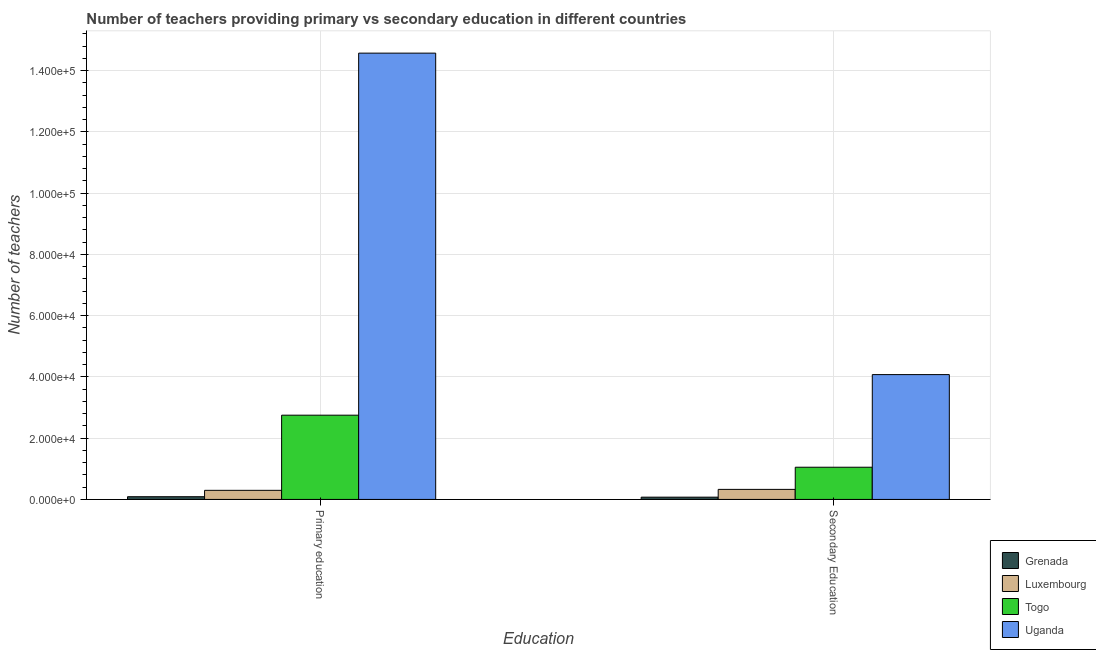How many different coloured bars are there?
Make the answer very short. 4. How many groups of bars are there?
Your response must be concise. 2. Are the number of bars per tick equal to the number of legend labels?
Your response must be concise. Yes. How many bars are there on the 2nd tick from the right?
Keep it short and to the point. 4. What is the number of primary teachers in Luxembourg?
Offer a very short reply. 2966. Across all countries, what is the maximum number of primary teachers?
Keep it short and to the point. 1.46e+05. Across all countries, what is the minimum number of primary teachers?
Offer a terse response. 888. In which country was the number of primary teachers maximum?
Keep it short and to the point. Uganda. In which country was the number of secondary teachers minimum?
Provide a succinct answer. Grenada. What is the total number of primary teachers in the graph?
Ensure brevity in your answer.  1.77e+05. What is the difference between the number of primary teachers in Togo and that in Luxembourg?
Provide a succinct answer. 2.45e+04. What is the difference between the number of primary teachers in Luxembourg and the number of secondary teachers in Uganda?
Offer a very short reply. -3.78e+04. What is the average number of secondary teachers per country?
Keep it short and to the point. 1.38e+04. What is the difference between the number of primary teachers and number of secondary teachers in Togo?
Provide a succinct answer. 1.70e+04. What is the ratio of the number of primary teachers in Uganda to that in Togo?
Offer a very short reply. 5.3. What does the 1st bar from the left in Primary education represents?
Keep it short and to the point. Grenada. What does the 1st bar from the right in Secondary Education represents?
Provide a short and direct response. Uganda. How many bars are there?
Your answer should be compact. 8. How many countries are there in the graph?
Keep it short and to the point. 4. What is the difference between two consecutive major ticks on the Y-axis?
Make the answer very short. 2.00e+04. Are the values on the major ticks of Y-axis written in scientific E-notation?
Give a very brief answer. Yes. Does the graph contain grids?
Keep it short and to the point. Yes. How are the legend labels stacked?
Your response must be concise. Vertical. What is the title of the graph?
Give a very brief answer. Number of teachers providing primary vs secondary education in different countries. What is the label or title of the X-axis?
Your response must be concise. Education. What is the label or title of the Y-axis?
Your answer should be very brief. Number of teachers. What is the Number of teachers of Grenada in Primary education?
Your answer should be compact. 888. What is the Number of teachers of Luxembourg in Primary education?
Offer a very short reply. 2966. What is the Number of teachers of Togo in Primary education?
Make the answer very short. 2.75e+04. What is the Number of teachers of Uganda in Primary education?
Ensure brevity in your answer.  1.46e+05. What is the Number of teachers of Grenada in Secondary Education?
Your response must be concise. 740. What is the Number of teachers in Luxembourg in Secondary Education?
Your response must be concise. 3279. What is the Number of teachers in Togo in Secondary Education?
Keep it short and to the point. 1.05e+04. What is the Number of teachers in Uganda in Secondary Education?
Provide a succinct answer. 4.08e+04. Across all Education, what is the maximum Number of teachers of Grenada?
Your answer should be very brief. 888. Across all Education, what is the maximum Number of teachers in Luxembourg?
Give a very brief answer. 3279. Across all Education, what is the maximum Number of teachers in Togo?
Make the answer very short. 2.75e+04. Across all Education, what is the maximum Number of teachers in Uganda?
Make the answer very short. 1.46e+05. Across all Education, what is the minimum Number of teachers in Grenada?
Keep it short and to the point. 740. Across all Education, what is the minimum Number of teachers of Luxembourg?
Provide a short and direct response. 2966. Across all Education, what is the minimum Number of teachers in Togo?
Your answer should be very brief. 1.05e+04. Across all Education, what is the minimum Number of teachers of Uganda?
Make the answer very short. 4.08e+04. What is the total Number of teachers of Grenada in the graph?
Make the answer very short. 1628. What is the total Number of teachers of Luxembourg in the graph?
Your answer should be very brief. 6245. What is the total Number of teachers of Togo in the graph?
Make the answer very short. 3.80e+04. What is the total Number of teachers of Uganda in the graph?
Your answer should be very brief. 1.86e+05. What is the difference between the Number of teachers in Grenada in Primary education and that in Secondary Education?
Offer a very short reply. 148. What is the difference between the Number of teachers of Luxembourg in Primary education and that in Secondary Education?
Ensure brevity in your answer.  -313. What is the difference between the Number of teachers in Togo in Primary education and that in Secondary Education?
Provide a succinct answer. 1.70e+04. What is the difference between the Number of teachers in Uganda in Primary education and that in Secondary Education?
Ensure brevity in your answer.  1.05e+05. What is the difference between the Number of teachers in Grenada in Primary education and the Number of teachers in Luxembourg in Secondary Education?
Keep it short and to the point. -2391. What is the difference between the Number of teachers in Grenada in Primary education and the Number of teachers in Togo in Secondary Education?
Your answer should be very brief. -9625. What is the difference between the Number of teachers of Grenada in Primary education and the Number of teachers of Uganda in Secondary Education?
Your answer should be compact. -3.99e+04. What is the difference between the Number of teachers of Luxembourg in Primary education and the Number of teachers of Togo in Secondary Education?
Keep it short and to the point. -7547. What is the difference between the Number of teachers of Luxembourg in Primary education and the Number of teachers of Uganda in Secondary Education?
Make the answer very short. -3.78e+04. What is the difference between the Number of teachers in Togo in Primary education and the Number of teachers in Uganda in Secondary Education?
Keep it short and to the point. -1.32e+04. What is the average Number of teachers in Grenada per Education?
Make the answer very short. 814. What is the average Number of teachers in Luxembourg per Education?
Your response must be concise. 3122.5. What is the average Number of teachers in Togo per Education?
Give a very brief answer. 1.90e+04. What is the average Number of teachers in Uganda per Education?
Give a very brief answer. 9.32e+04. What is the difference between the Number of teachers in Grenada and Number of teachers in Luxembourg in Primary education?
Ensure brevity in your answer.  -2078. What is the difference between the Number of teachers in Grenada and Number of teachers in Togo in Primary education?
Keep it short and to the point. -2.66e+04. What is the difference between the Number of teachers in Grenada and Number of teachers in Uganda in Primary education?
Make the answer very short. -1.45e+05. What is the difference between the Number of teachers in Luxembourg and Number of teachers in Togo in Primary education?
Your answer should be compact. -2.45e+04. What is the difference between the Number of teachers in Luxembourg and Number of teachers in Uganda in Primary education?
Offer a very short reply. -1.43e+05. What is the difference between the Number of teachers in Togo and Number of teachers in Uganda in Primary education?
Give a very brief answer. -1.18e+05. What is the difference between the Number of teachers in Grenada and Number of teachers in Luxembourg in Secondary Education?
Keep it short and to the point. -2539. What is the difference between the Number of teachers in Grenada and Number of teachers in Togo in Secondary Education?
Your response must be concise. -9773. What is the difference between the Number of teachers of Grenada and Number of teachers of Uganda in Secondary Education?
Offer a very short reply. -4.00e+04. What is the difference between the Number of teachers in Luxembourg and Number of teachers in Togo in Secondary Education?
Ensure brevity in your answer.  -7234. What is the difference between the Number of teachers in Luxembourg and Number of teachers in Uganda in Secondary Education?
Offer a very short reply. -3.75e+04. What is the difference between the Number of teachers of Togo and Number of teachers of Uganda in Secondary Education?
Give a very brief answer. -3.02e+04. What is the ratio of the Number of teachers of Grenada in Primary education to that in Secondary Education?
Your answer should be compact. 1.2. What is the ratio of the Number of teachers in Luxembourg in Primary education to that in Secondary Education?
Offer a terse response. 0.9. What is the ratio of the Number of teachers of Togo in Primary education to that in Secondary Education?
Your response must be concise. 2.62. What is the ratio of the Number of teachers in Uganda in Primary education to that in Secondary Education?
Keep it short and to the point. 3.58. What is the difference between the highest and the second highest Number of teachers in Grenada?
Ensure brevity in your answer.  148. What is the difference between the highest and the second highest Number of teachers in Luxembourg?
Your response must be concise. 313. What is the difference between the highest and the second highest Number of teachers in Togo?
Your response must be concise. 1.70e+04. What is the difference between the highest and the second highest Number of teachers in Uganda?
Ensure brevity in your answer.  1.05e+05. What is the difference between the highest and the lowest Number of teachers in Grenada?
Your answer should be compact. 148. What is the difference between the highest and the lowest Number of teachers of Luxembourg?
Keep it short and to the point. 313. What is the difference between the highest and the lowest Number of teachers in Togo?
Provide a short and direct response. 1.70e+04. What is the difference between the highest and the lowest Number of teachers of Uganda?
Offer a terse response. 1.05e+05. 